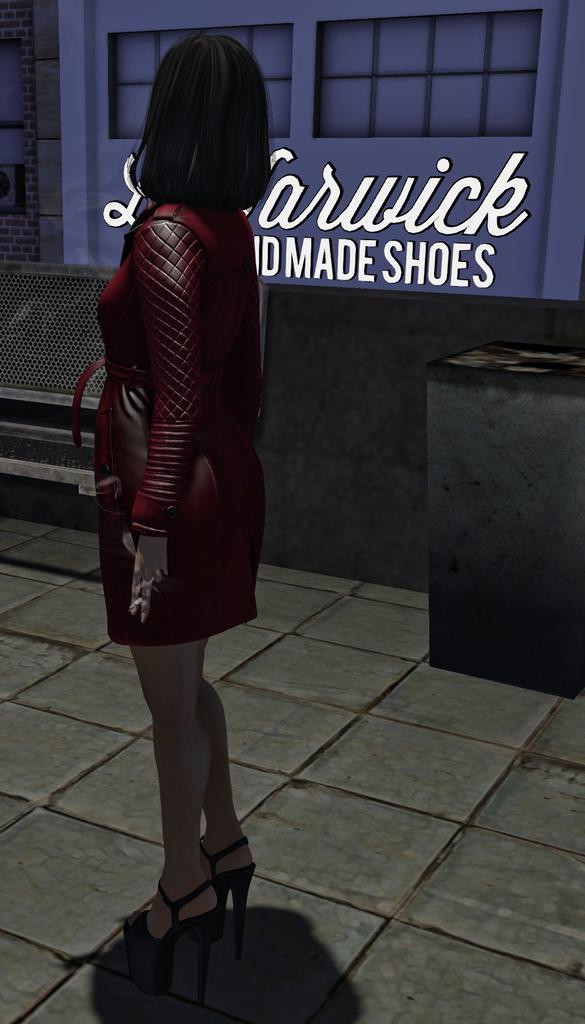Can you describe this image briefly? This is an animation, in this image in the foreground there is one woman and in the background there is a building. On the building there is text, all, net and some box. At the bottom there is walkway. 